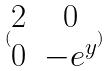Convert formula to latex. <formula><loc_0><loc_0><loc_500><loc_500>( \begin{matrix} 2 & 0 \\ 0 & - e ^ { y } \end{matrix} )</formula> 